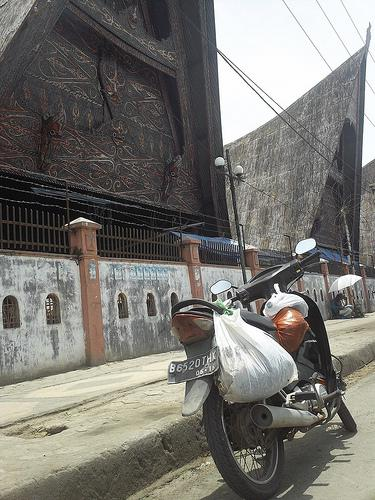Question: what kind of vehicle is pictured?
Choices:
A. Motorcycle.
B. Car.
C. Bicycle.
D. Buggy.
Answer with the letter. Answer: A Question: what color is the umbrella?
Choices:
A. Black.
B. Red.
C. Blue.
D. White.
Answer with the letter. Answer: D Question: how many people are in the picture?
Choices:
A. 1.
B. 2.
C. 3.
D. 4.
Answer with the letter. Answer: A Question: what side of the motorcycle are we looking at?
Choices:
A. Right.
B. Left.
C. Front.
D. Back.
Answer with the letter. Answer: A Question: how many bags do you see on the motorcycle?
Choices:
A. 4.
B. 3.
C. 5.
D. 6.
Answer with the letter. Answer: B 